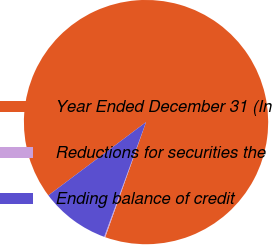Convert chart. <chart><loc_0><loc_0><loc_500><loc_500><pie_chart><fcel>Year Ended December 31 (In<fcel>Reductions for securities the<fcel>Ending balance of credit<nl><fcel>90.68%<fcel>0.14%<fcel>9.19%<nl></chart> 